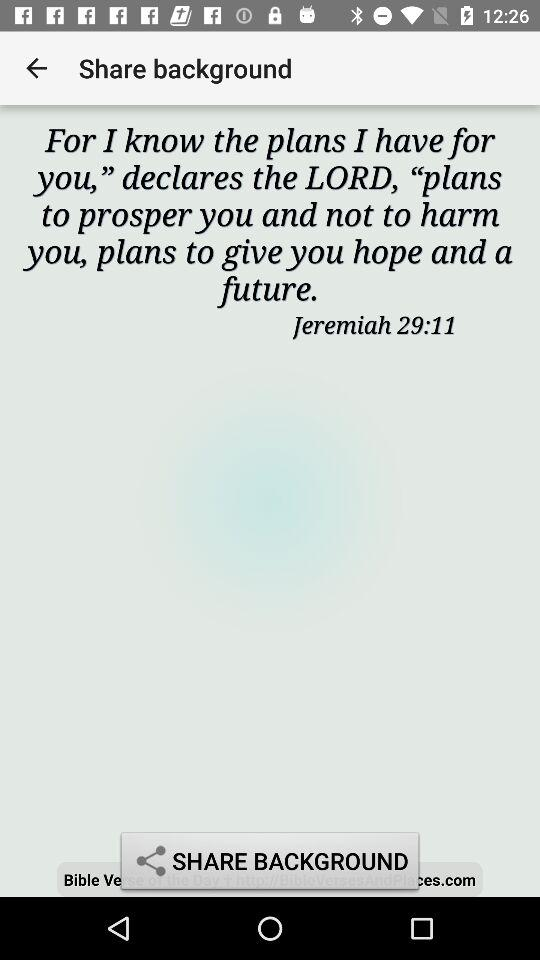What is the name of the user? The name of the user is "Jeremiah". 